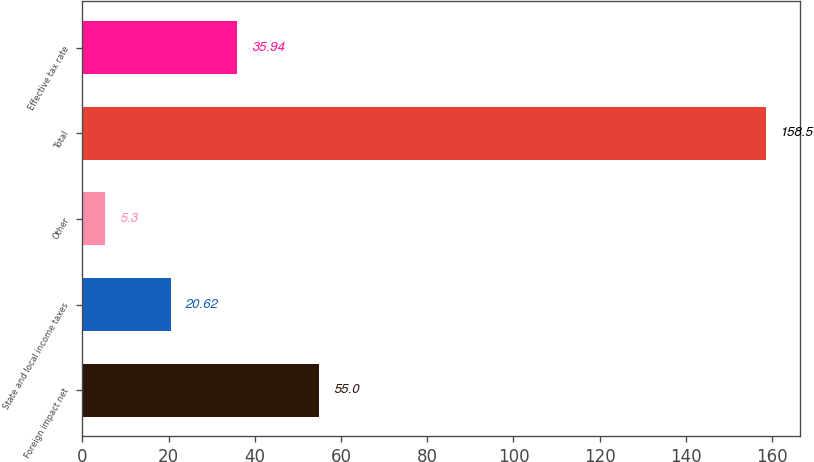<chart> <loc_0><loc_0><loc_500><loc_500><bar_chart><fcel>Foreign impact net<fcel>State and local income taxes<fcel>Other<fcel>Total<fcel>Effective tax rate<nl><fcel>55<fcel>20.62<fcel>5.3<fcel>158.5<fcel>35.94<nl></chart> 